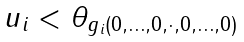Convert formula to latex. <formula><loc_0><loc_0><loc_500><loc_500>\begin{array} { l } u _ { i } < \theta _ { g _ { i } ( 0 , \dots , 0 , \cdot , 0 , \dots , 0 ) } \end{array}</formula> 